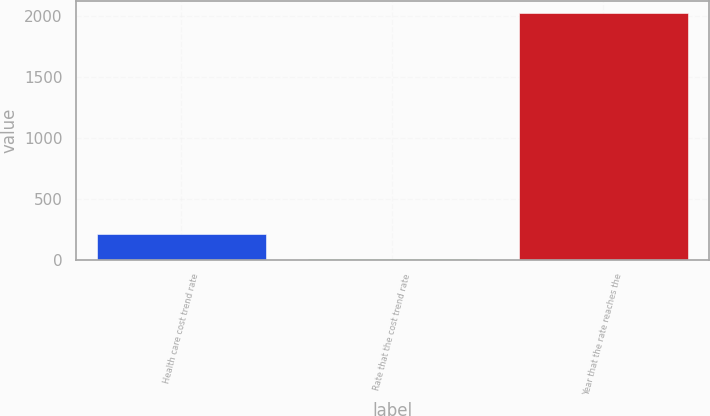Convert chart to OTSL. <chart><loc_0><loc_0><loc_500><loc_500><bar_chart><fcel>Health care cost trend rate<fcel>Rate that the cost trend rate<fcel>Year that the rate reaches the<nl><fcel>206.7<fcel>5<fcel>2022<nl></chart> 